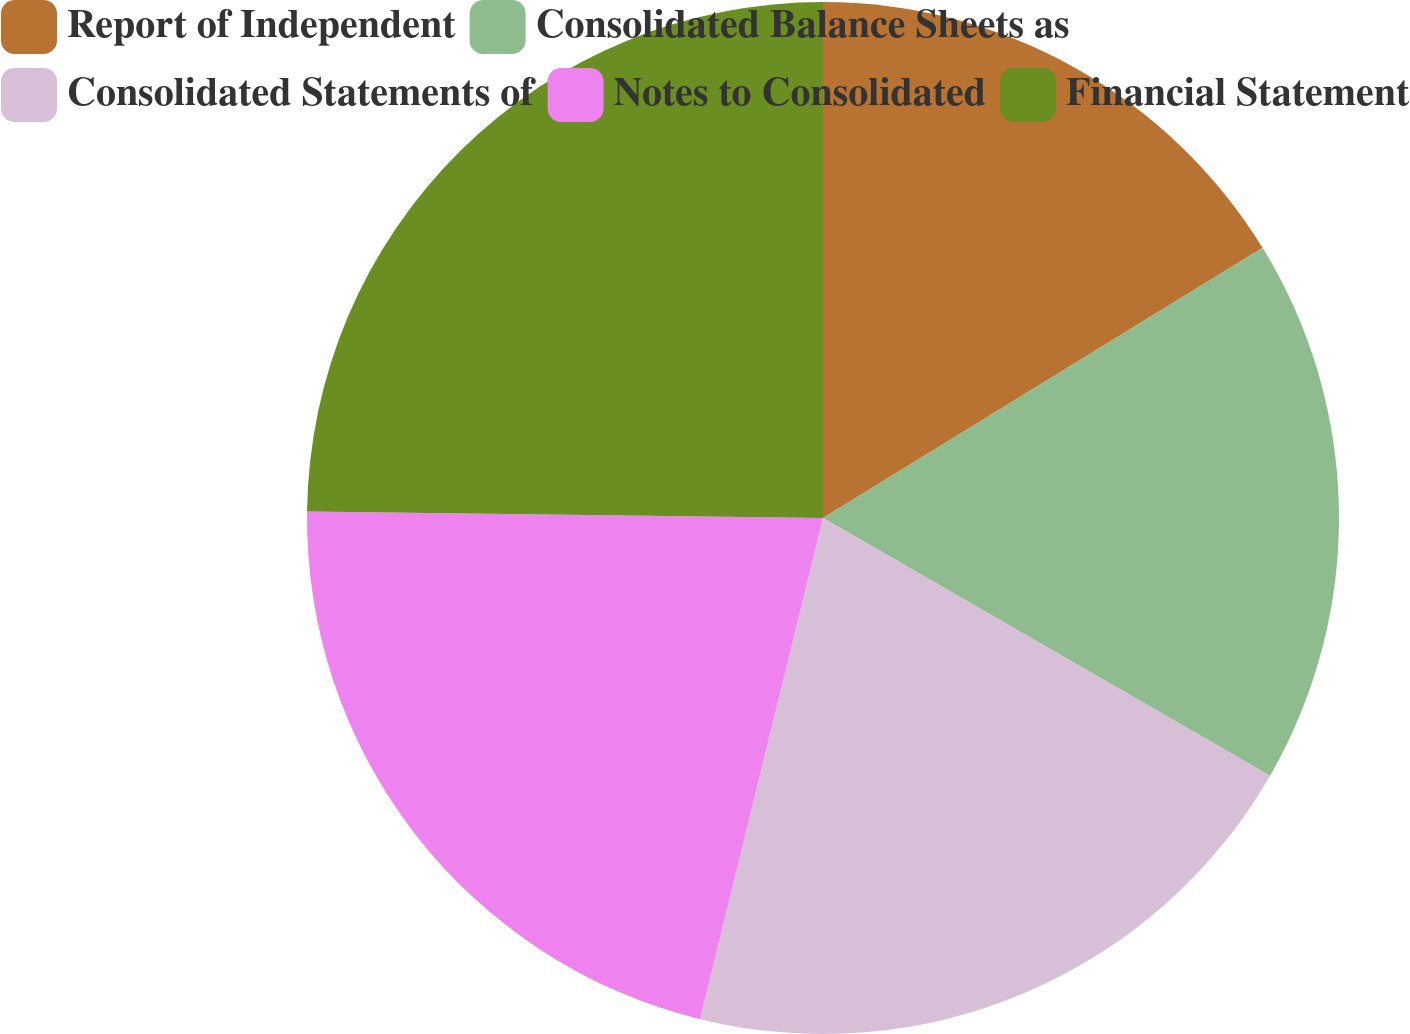<chart> <loc_0><loc_0><loc_500><loc_500><pie_chart><fcel>Report of Independent<fcel>Consolidated Balance Sheets as<fcel>Consolidated Statements of<fcel>Notes to Consolidated<fcel>Financial Statement<nl><fcel>16.23%<fcel>17.09%<fcel>20.51%<fcel>21.37%<fcel>24.8%<nl></chart> 